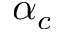<formula> <loc_0><loc_0><loc_500><loc_500>\alpha _ { c }</formula> 